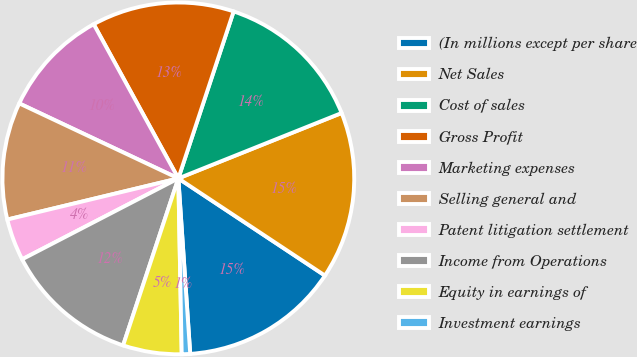Convert chart. <chart><loc_0><loc_0><loc_500><loc_500><pie_chart><fcel>(In millions except per share<fcel>Net Sales<fcel>Cost of sales<fcel>Gross Profit<fcel>Marketing expenses<fcel>Selling general and<fcel>Patent litigation settlement<fcel>Income from Operations<fcel>Equity in earnings of<fcel>Investment earnings<nl><fcel>14.61%<fcel>15.38%<fcel>13.85%<fcel>13.08%<fcel>10.0%<fcel>10.77%<fcel>3.85%<fcel>12.31%<fcel>5.39%<fcel>0.77%<nl></chart> 